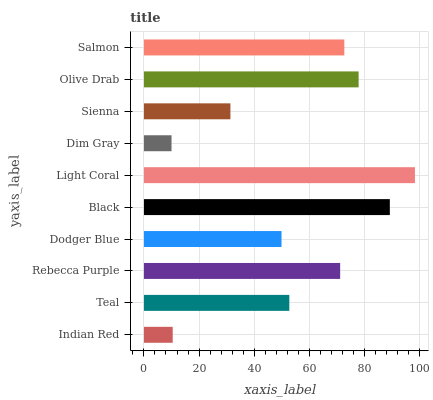Is Dim Gray the minimum?
Answer yes or no. Yes. Is Light Coral the maximum?
Answer yes or no. Yes. Is Teal the minimum?
Answer yes or no. No. Is Teal the maximum?
Answer yes or no. No. Is Teal greater than Indian Red?
Answer yes or no. Yes. Is Indian Red less than Teal?
Answer yes or no. Yes. Is Indian Red greater than Teal?
Answer yes or no. No. Is Teal less than Indian Red?
Answer yes or no. No. Is Rebecca Purple the high median?
Answer yes or no. Yes. Is Teal the low median?
Answer yes or no. Yes. Is Salmon the high median?
Answer yes or no. No. Is Dodger Blue the low median?
Answer yes or no. No. 